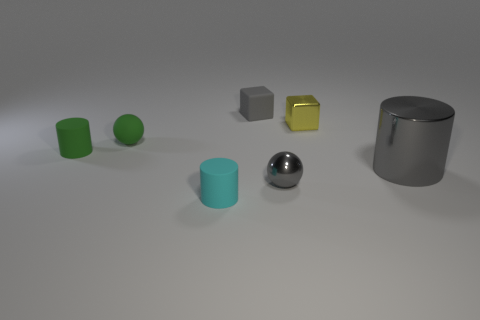Add 2 green rubber objects. How many objects exist? 9 Subtract all cylinders. How many objects are left? 4 Add 5 big purple shiny cylinders. How many big purple shiny cylinders exist? 5 Subtract 0 red cylinders. How many objects are left? 7 Subtract all small cyan shiny balls. Subtract all small cyan rubber cylinders. How many objects are left? 6 Add 3 gray cylinders. How many gray cylinders are left? 4 